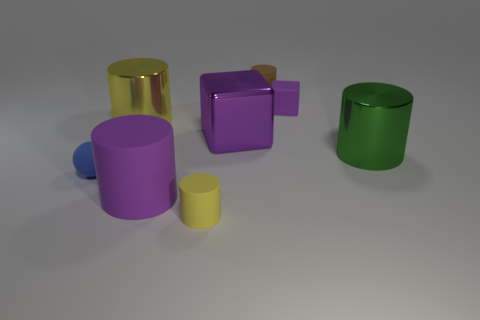There is a yellow cylinder in front of the matte thing to the left of the purple cylinder; is there a metallic cylinder right of it?
Make the answer very short. Yes. There is a purple cylinder that is the same material as the brown thing; what size is it?
Your answer should be very brief. Large. There is a big purple block; are there any large purple objects to the right of it?
Keep it short and to the point. No. There is a large purple thing in front of the big green metallic thing; is there a object that is in front of it?
Offer a very short reply. Yes. There is a metallic cylinder on the right side of the small yellow cylinder; is its size the same as the yellow cylinder that is in front of the big green cylinder?
Ensure brevity in your answer.  No. What number of large things are either blue blocks or green metal objects?
Give a very brief answer. 1. There is a big purple thing on the right side of the big purple object that is in front of the rubber sphere; what is it made of?
Make the answer very short. Metal. There is another matte thing that is the same color as the large rubber thing; what is its shape?
Offer a very short reply. Cube. Are there any green things that have the same material as the tiny blue object?
Make the answer very short. No. Is the material of the blue object the same as the yellow object that is behind the big purple metal block?
Give a very brief answer. No. 